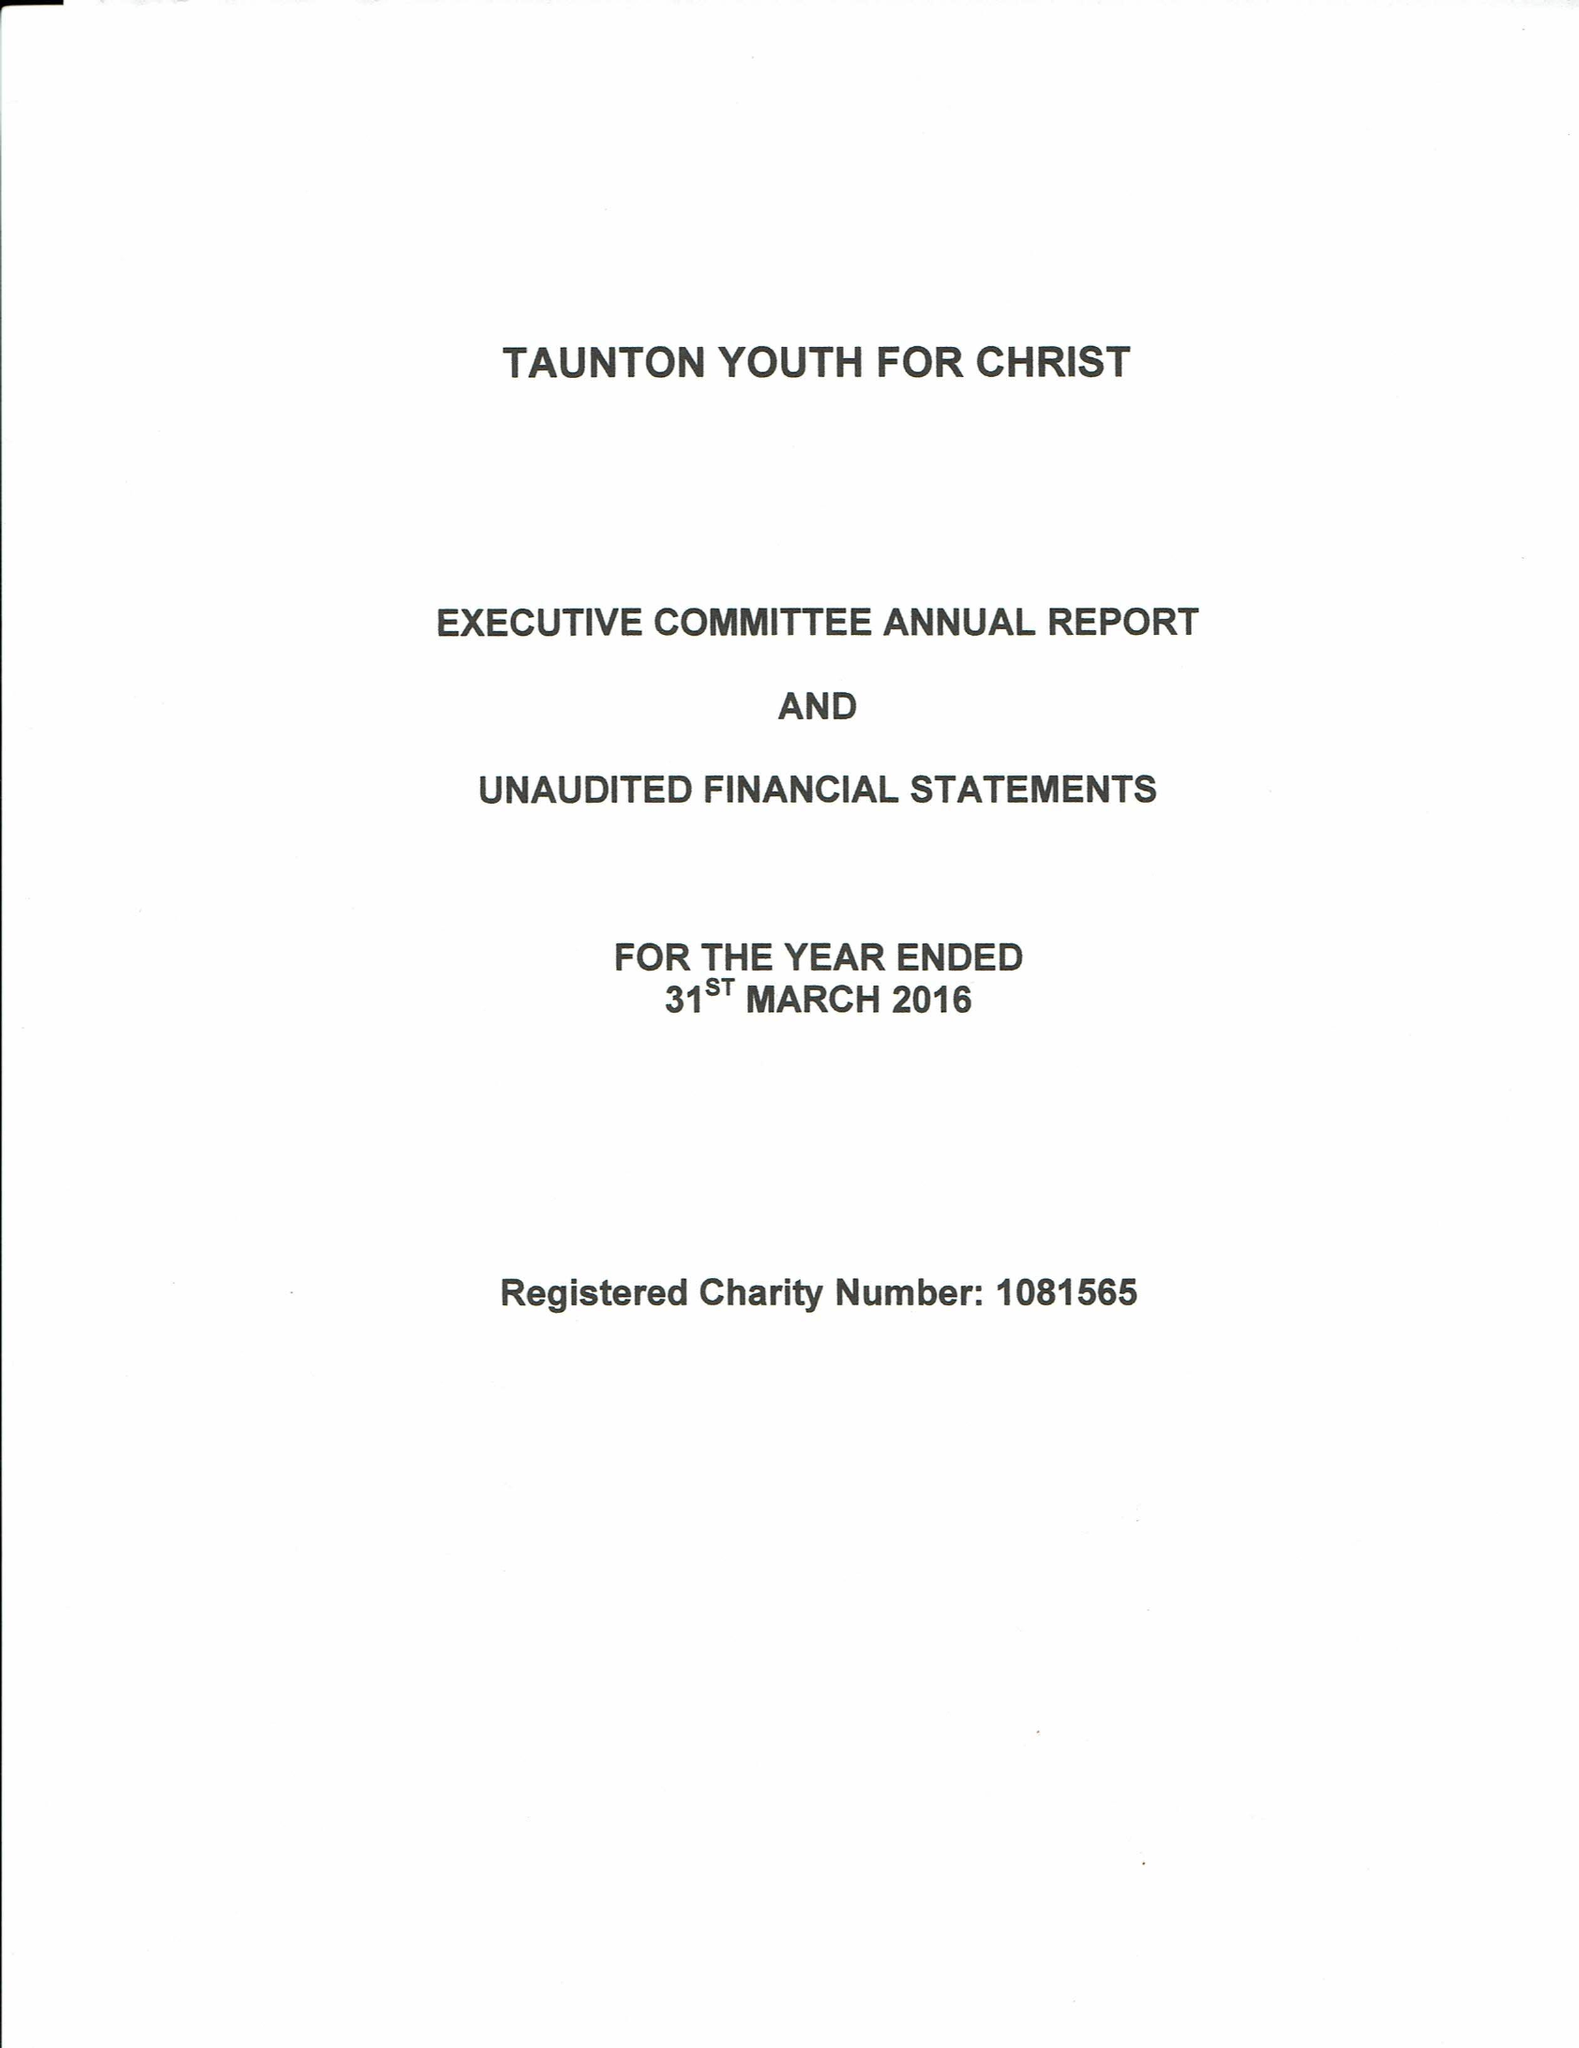What is the value for the charity_number?
Answer the question using a single word or phrase. 1081565 